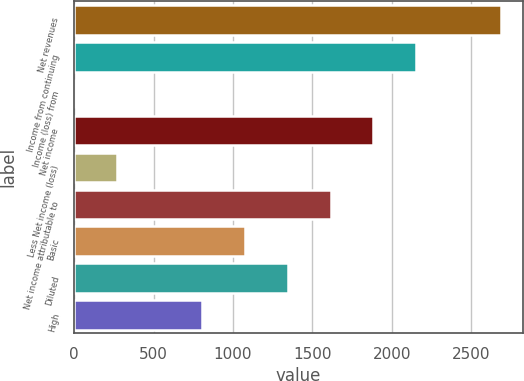Convert chart to OTSL. <chart><loc_0><loc_0><loc_500><loc_500><bar_chart><fcel>Net revenues<fcel>Income from continuing<fcel>Income (loss) from<fcel>Net income<fcel>Less Net income (loss)<fcel>Net income attributable to<fcel>Basic<fcel>Diluted<fcel>High<nl><fcel>2691<fcel>2153<fcel>1<fcel>1884<fcel>270<fcel>1615<fcel>1077<fcel>1346<fcel>808<nl></chart> 